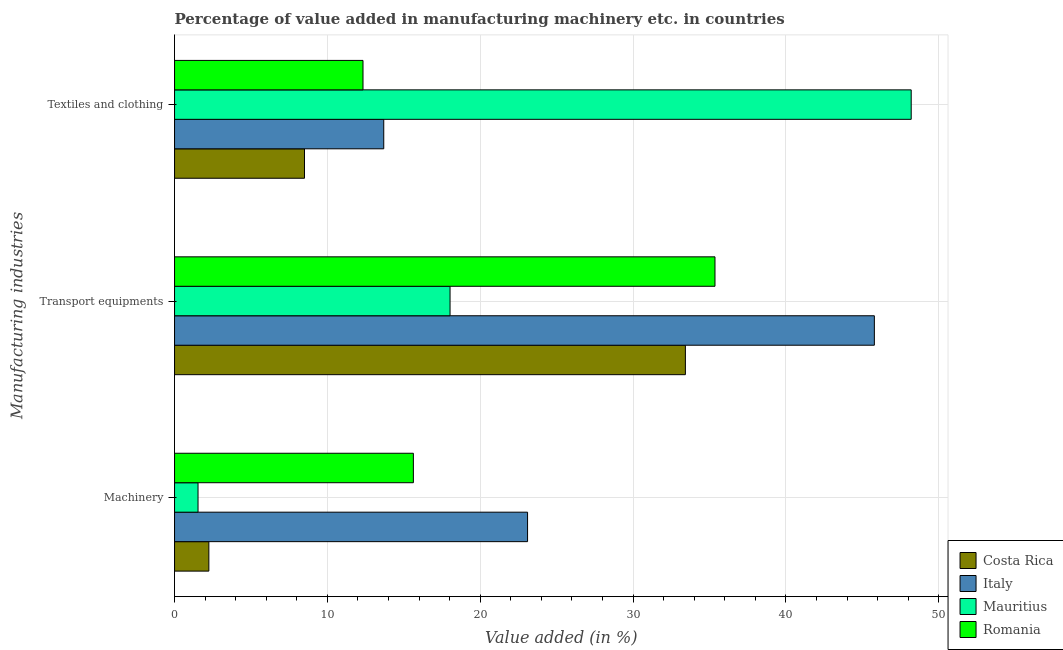How many groups of bars are there?
Make the answer very short. 3. Are the number of bars per tick equal to the number of legend labels?
Your answer should be very brief. Yes. How many bars are there on the 2nd tick from the top?
Offer a very short reply. 4. What is the label of the 1st group of bars from the top?
Your answer should be compact. Textiles and clothing. What is the value added in manufacturing transport equipments in Mauritius?
Your response must be concise. 18.02. Across all countries, what is the maximum value added in manufacturing textile and clothing?
Provide a short and direct response. 48.19. Across all countries, what is the minimum value added in manufacturing machinery?
Ensure brevity in your answer.  1.54. In which country was the value added in manufacturing machinery maximum?
Provide a short and direct response. Italy. In which country was the value added in manufacturing textile and clothing minimum?
Offer a very short reply. Costa Rica. What is the total value added in manufacturing textile and clothing in the graph?
Your answer should be compact. 82.71. What is the difference between the value added in manufacturing transport equipments in Costa Rica and that in Italy?
Make the answer very short. -12.36. What is the difference between the value added in manufacturing transport equipments in Romania and the value added in manufacturing textile and clothing in Mauritius?
Your answer should be compact. -12.84. What is the average value added in manufacturing machinery per country?
Offer a terse response. 10.62. What is the difference between the value added in manufacturing transport equipments and value added in manufacturing machinery in Romania?
Provide a short and direct response. 19.73. In how many countries, is the value added in manufacturing textile and clothing greater than 40 %?
Your response must be concise. 1. What is the ratio of the value added in manufacturing machinery in Costa Rica to that in Italy?
Provide a succinct answer. 0.1. Is the value added in manufacturing textile and clothing in Italy less than that in Mauritius?
Provide a short and direct response. Yes. What is the difference between the highest and the second highest value added in manufacturing transport equipments?
Make the answer very short. 10.43. What is the difference between the highest and the lowest value added in manufacturing textile and clothing?
Provide a short and direct response. 39.69. Is the sum of the value added in manufacturing textile and clothing in Romania and Mauritius greater than the maximum value added in manufacturing transport equipments across all countries?
Your answer should be very brief. Yes. What does the 1st bar from the top in Transport equipments represents?
Provide a short and direct response. Romania. What does the 4th bar from the bottom in Transport equipments represents?
Your response must be concise. Romania. Is it the case that in every country, the sum of the value added in manufacturing machinery and value added in manufacturing transport equipments is greater than the value added in manufacturing textile and clothing?
Keep it short and to the point. No. How many countries are there in the graph?
Keep it short and to the point. 4. What is the difference between two consecutive major ticks on the X-axis?
Your answer should be compact. 10. Does the graph contain grids?
Your response must be concise. Yes. Where does the legend appear in the graph?
Make the answer very short. Bottom right. How many legend labels are there?
Ensure brevity in your answer.  4. What is the title of the graph?
Make the answer very short. Percentage of value added in manufacturing machinery etc. in countries. What is the label or title of the X-axis?
Ensure brevity in your answer.  Value added (in %). What is the label or title of the Y-axis?
Provide a short and direct response. Manufacturing industries. What is the Value added (in %) of Costa Rica in Machinery?
Keep it short and to the point. 2.24. What is the Value added (in %) in Italy in Machinery?
Make the answer very short. 23.09. What is the Value added (in %) of Mauritius in Machinery?
Give a very brief answer. 1.54. What is the Value added (in %) in Romania in Machinery?
Ensure brevity in your answer.  15.62. What is the Value added (in %) in Costa Rica in Transport equipments?
Offer a terse response. 33.42. What is the Value added (in %) in Italy in Transport equipments?
Offer a terse response. 45.78. What is the Value added (in %) of Mauritius in Transport equipments?
Your response must be concise. 18.02. What is the Value added (in %) in Romania in Transport equipments?
Provide a succinct answer. 35.36. What is the Value added (in %) of Costa Rica in Textiles and clothing?
Give a very brief answer. 8.5. What is the Value added (in %) of Italy in Textiles and clothing?
Offer a terse response. 13.69. What is the Value added (in %) of Mauritius in Textiles and clothing?
Your answer should be very brief. 48.19. What is the Value added (in %) of Romania in Textiles and clothing?
Your answer should be very brief. 12.33. Across all Manufacturing industries, what is the maximum Value added (in %) in Costa Rica?
Offer a terse response. 33.42. Across all Manufacturing industries, what is the maximum Value added (in %) of Italy?
Ensure brevity in your answer.  45.78. Across all Manufacturing industries, what is the maximum Value added (in %) in Mauritius?
Make the answer very short. 48.19. Across all Manufacturing industries, what is the maximum Value added (in %) of Romania?
Give a very brief answer. 35.36. Across all Manufacturing industries, what is the minimum Value added (in %) in Costa Rica?
Keep it short and to the point. 2.24. Across all Manufacturing industries, what is the minimum Value added (in %) of Italy?
Provide a succinct answer. 13.69. Across all Manufacturing industries, what is the minimum Value added (in %) in Mauritius?
Offer a terse response. 1.54. Across all Manufacturing industries, what is the minimum Value added (in %) of Romania?
Offer a terse response. 12.33. What is the total Value added (in %) in Costa Rica in the graph?
Provide a succinct answer. 44.16. What is the total Value added (in %) of Italy in the graph?
Keep it short and to the point. 82.56. What is the total Value added (in %) in Mauritius in the graph?
Make the answer very short. 67.75. What is the total Value added (in %) of Romania in the graph?
Offer a very short reply. 63.31. What is the difference between the Value added (in %) of Costa Rica in Machinery and that in Transport equipments?
Offer a very short reply. -31.17. What is the difference between the Value added (in %) in Italy in Machinery and that in Transport equipments?
Give a very brief answer. -22.69. What is the difference between the Value added (in %) of Mauritius in Machinery and that in Transport equipments?
Offer a terse response. -16.49. What is the difference between the Value added (in %) in Romania in Machinery and that in Transport equipments?
Your answer should be very brief. -19.73. What is the difference between the Value added (in %) in Costa Rica in Machinery and that in Textiles and clothing?
Keep it short and to the point. -6.26. What is the difference between the Value added (in %) in Italy in Machinery and that in Textiles and clothing?
Your response must be concise. 9.41. What is the difference between the Value added (in %) of Mauritius in Machinery and that in Textiles and clothing?
Make the answer very short. -46.66. What is the difference between the Value added (in %) of Romania in Machinery and that in Textiles and clothing?
Your answer should be compact. 3.29. What is the difference between the Value added (in %) of Costa Rica in Transport equipments and that in Textiles and clothing?
Your answer should be compact. 24.92. What is the difference between the Value added (in %) of Italy in Transport equipments and that in Textiles and clothing?
Keep it short and to the point. 32.1. What is the difference between the Value added (in %) of Mauritius in Transport equipments and that in Textiles and clothing?
Keep it short and to the point. -30.17. What is the difference between the Value added (in %) of Romania in Transport equipments and that in Textiles and clothing?
Give a very brief answer. 23.03. What is the difference between the Value added (in %) of Costa Rica in Machinery and the Value added (in %) of Italy in Transport equipments?
Make the answer very short. -43.54. What is the difference between the Value added (in %) in Costa Rica in Machinery and the Value added (in %) in Mauritius in Transport equipments?
Offer a very short reply. -15.78. What is the difference between the Value added (in %) of Costa Rica in Machinery and the Value added (in %) of Romania in Transport equipments?
Offer a very short reply. -33.11. What is the difference between the Value added (in %) in Italy in Machinery and the Value added (in %) in Mauritius in Transport equipments?
Your answer should be very brief. 5.07. What is the difference between the Value added (in %) of Italy in Machinery and the Value added (in %) of Romania in Transport equipments?
Your answer should be compact. -12.26. What is the difference between the Value added (in %) in Mauritius in Machinery and the Value added (in %) in Romania in Transport equipments?
Your answer should be compact. -33.82. What is the difference between the Value added (in %) of Costa Rica in Machinery and the Value added (in %) of Italy in Textiles and clothing?
Give a very brief answer. -11.44. What is the difference between the Value added (in %) of Costa Rica in Machinery and the Value added (in %) of Mauritius in Textiles and clothing?
Your answer should be compact. -45.95. What is the difference between the Value added (in %) in Costa Rica in Machinery and the Value added (in %) in Romania in Textiles and clothing?
Your response must be concise. -10.08. What is the difference between the Value added (in %) of Italy in Machinery and the Value added (in %) of Mauritius in Textiles and clothing?
Give a very brief answer. -25.1. What is the difference between the Value added (in %) of Italy in Machinery and the Value added (in %) of Romania in Textiles and clothing?
Your answer should be very brief. 10.77. What is the difference between the Value added (in %) in Mauritius in Machinery and the Value added (in %) in Romania in Textiles and clothing?
Provide a short and direct response. -10.79. What is the difference between the Value added (in %) in Costa Rica in Transport equipments and the Value added (in %) in Italy in Textiles and clothing?
Offer a terse response. 19.73. What is the difference between the Value added (in %) of Costa Rica in Transport equipments and the Value added (in %) of Mauritius in Textiles and clothing?
Keep it short and to the point. -14.77. What is the difference between the Value added (in %) of Costa Rica in Transport equipments and the Value added (in %) of Romania in Textiles and clothing?
Offer a very short reply. 21.09. What is the difference between the Value added (in %) of Italy in Transport equipments and the Value added (in %) of Mauritius in Textiles and clothing?
Keep it short and to the point. -2.41. What is the difference between the Value added (in %) of Italy in Transport equipments and the Value added (in %) of Romania in Textiles and clothing?
Offer a terse response. 33.45. What is the difference between the Value added (in %) in Mauritius in Transport equipments and the Value added (in %) in Romania in Textiles and clothing?
Keep it short and to the point. 5.69. What is the average Value added (in %) of Costa Rica per Manufacturing industries?
Provide a succinct answer. 14.72. What is the average Value added (in %) in Italy per Manufacturing industries?
Offer a very short reply. 27.52. What is the average Value added (in %) in Mauritius per Manufacturing industries?
Keep it short and to the point. 22.58. What is the average Value added (in %) of Romania per Manufacturing industries?
Your answer should be very brief. 21.1. What is the difference between the Value added (in %) in Costa Rica and Value added (in %) in Italy in Machinery?
Your response must be concise. -20.85. What is the difference between the Value added (in %) of Costa Rica and Value added (in %) of Mauritius in Machinery?
Your response must be concise. 0.71. What is the difference between the Value added (in %) in Costa Rica and Value added (in %) in Romania in Machinery?
Your answer should be compact. -13.38. What is the difference between the Value added (in %) in Italy and Value added (in %) in Mauritius in Machinery?
Offer a very short reply. 21.56. What is the difference between the Value added (in %) in Italy and Value added (in %) in Romania in Machinery?
Your answer should be compact. 7.47. What is the difference between the Value added (in %) of Mauritius and Value added (in %) of Romania in Machinery?
Give a very brief answer. -14.09. What is the difference between the Value added (in %) in Costa Rica and Value added (in %) in Italy in Transport equipments?
Ensure brevity in your answer.  -12.36. What is the difference between the Value added (in %) in Costa Rica and Value added (in %) in Mauritius in Transport equipments?
Your response must be concise. 15.4. What is the difference between the Value added (in %) in Costa Rica and Value added (in %) in Romania in Transport equipments?
Ensure brevity in your answer.  -1.94. What is the difference between the Value added (in %) in Italy and Value added (in %) in Mauritius in Transport equipments?
Provide a short and direct response. 27.76. What is the difference between the Value added (in %) in Italy and Value added (in %) in Romania in Transport equipments?
Make the answer very short. 10.43. What is the difference between the Value added (in %) of Mauritius and Value added (in %) of Romania in Transport equipments?
Offer a very short reply. -17.33. What is the difference between the Value added (in %) of Costa Rica and Value added (in %) of Italy in Textiles and clothing?
Give a very brief answer. -5.19. What is the difference between the Value added (in %) in Costa Rica and Value added (in %) in Mauritius in Textiles and clothing?
Provide a succinct answer. -39.69. What is the difference between the Value added (in %) of Costa Rica and Value added (in %) of Romania in Textiles and clothing?
Your answer should be very brief. -3.83. What is the difference between the Value added (in %) of Italy and Value added (in %) of Mauritius in Textiles and clothing?
Give a very brief answer. -34.51. What is the difference between the Value added (in %) in Italy and Value added (in %) in Romania in Textiles and clothing?
Ensure brevity in your answer.  1.36. What is the difference between the Value added (in %) in Mauritius and Value added (in %) in Romania in Textiles and clothing?
Give a very brief answer. 35.86. What is the ratio of the Value added (in %) in Costa Rica in Machinery to that in Transport equipments?
Give a very brief answer. 0.07. What is the ratio of the Value added (in %) in Italy in Machinery to that in Transport equipments?
Ensure brevity in your answer.  0.5. What is the ratio of the Value added (in %) in Mauritius in Machinery to that in Transport equipments?
Give a very brief answer. 0.09. What is the ratio of the Value added (in %) in Romania in Machinery to that in Transport equipments?
Make the answer very short. 0.44. What is the ratio of the Value added (in %) of Costa Rica in Machinery to that in Textiles and clothing?
Your answer should be compact. 0.26. What is the ratio of the Value added (in %) in Italy in Machinery to that in Textiles and clothing?
Provide a succinct answer. 1.69. What is the ratio of the Value added (in %) in Mauritius in Machinery to that in Textiles and clothing?
Offer a very short reply. 0.03. What is the ratio of the Value added (in %) in Romania in Machinery to that in Textiles and clothing?
Give a very brief answer. 1.27. What is the ratio of the Value added (in %) in Costa Rica in Transport equipments to that in Textiles and clothing?
Ensure brevity in your answer.  3.93. What is the ratio of the Value added (in %) of Italy in Transport equipments to that in Textiles and clothing?
Provide a succinct answer. 3.35. What is the ratio of the Value added (in %) of Mauritius in Transport equipments to that in Textiles and clothing?
Provide a short and direct response. 0.37. What is the ratio of the Value added (in %) of Romania in Transport equipments to that in Textiles and clothing?
Your answer should be compact. 2.87. What is the difference between the highest and the second highest Value added (in %) of Costa Rica?
Keep it short and to the point. 24.92. What is the difference between the highest and the second highest Value added (in %) of Italy?
Provide a short and direct response. 22.69. What is the difference between the highest and the second highest Value added (in %) of Mauritius?
Your answer should be compact. 30.17. What is the difference between the highest and the second highest Value added (in %) in Romania?
Offer a very short reply. 19.73. What is the difference between the highest and the lowest Value added (in %) of Costa Rica?
Offer a terse response. 31.17. What is the difference between the highest and the lowest Value added (in %) of Italy?
Make the answer very short. 32.1. What is the difference between the highest and the lowest Value added (in %) of Mauritius?
Offer a very short reply. 46.66. What is the difference between the highest and the lowest Value added (in %) of Romania?
Offer a terse response. 23.03. 